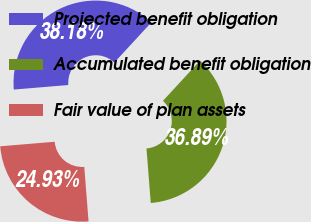Convert chart to OTSL. <chart><loc_0><loc_0><loc_500><loc_500><pie_chart><fcel>Projected benefit obligation<fcel>Accumulated benefit obligation<fcel>Fair value of plan assets<nl><fcel>38.18%<fcel>36.89%<fcel>24.93%<nl></chart> 